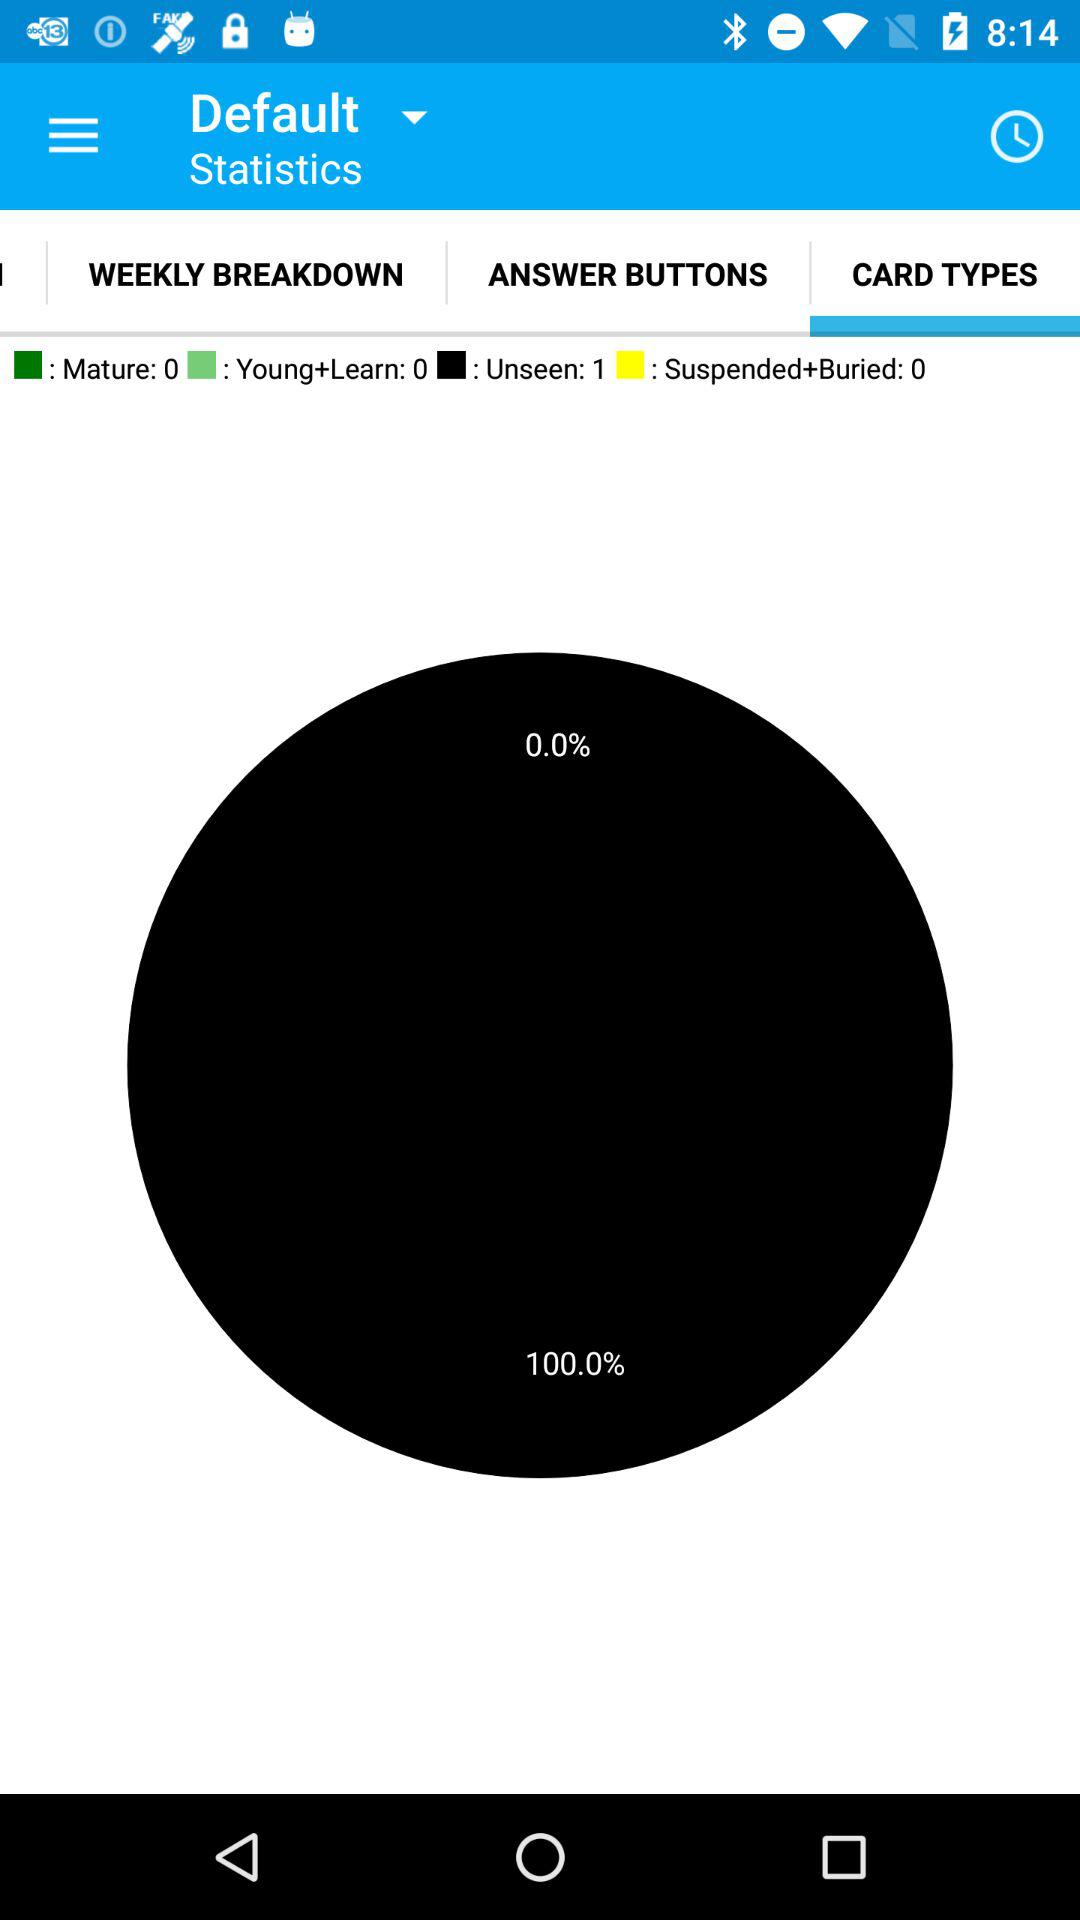How many more unseen cards than mature cards are there?
Answer the question using a single word or phrase. 1 